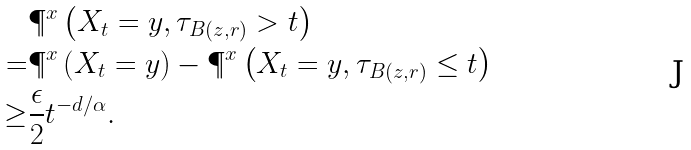Convert formula to latex. <formula><loc_0><loc_0><loc_500><loc_500>& \P ^ { x } \left ( X _ { t } = y , \tau _ { B ( z , r ) } > t \right ) \\ = & \P ^ { x } \left ( X _ { t } = y \right ) - \P ^ { x } \left ( X _ { t } = y , \tau _ { B ( z , r ) } \leq t \right ) \\ \geq & \frac { \epsilon } { 2 } t ^ { - d / \alpha } .</formula> 